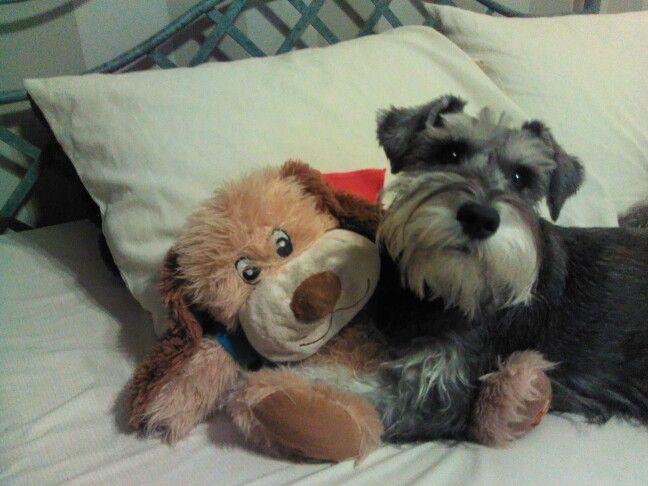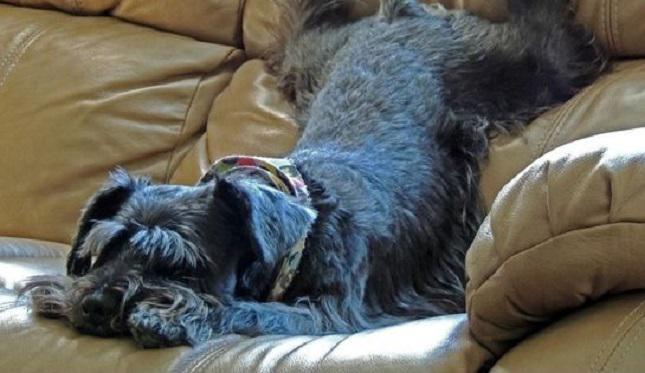The first image is the image on the left, the second image is the image on the right. Evaluate the accuracy of this statement regarding the images: "There are more dogs in the image on the right.". Is it true? Answer yes or no. No. 